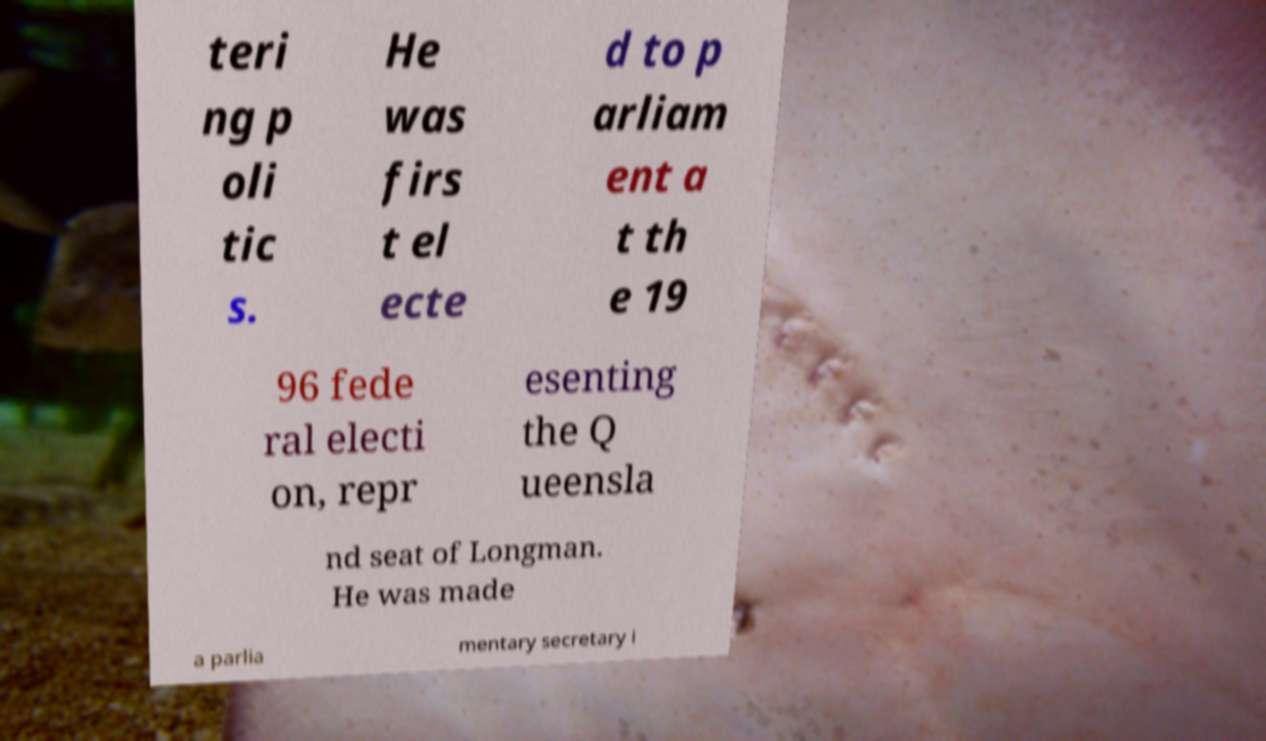Please read and relay the text visible in this image. What does it say? teri ng p oli tic s. He was firs t el ecte d to p arliam ent a t th e 19 96 fede ral electi on, repr esenting the Q ueensla nd seat of Longman. He was made a parlia mentary secretary i 